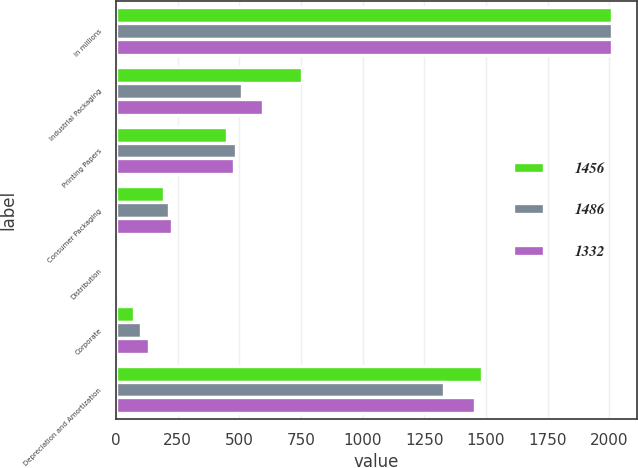Convert chart. <chart><loc_0><loc_0><loc_500><loc_500><stacked_bar_chart><ecel><fcel>In millions<fcel>Industrial Packaging<fcel>Printing Papers<fcel>Consumer Packaging<fcel>Distribution<fcel>Corporate<fcel>Depreciation and Amortization<nl><fcel>1456<fcel>2012<fcel>755<fcel>450<fcel>196<fcel>13<fcel>72<fcel>1486<nl><fcel>1486<fcel>2011<fcel>513<fcel>486<fcel>217<fcel>14<fcel>102<fcel>1332<nl><fcel>1332<fcel>2010<fcel>597<fcel>479<fcel>228<fcel>13<fcel>134<fcel>1456<nl></chart> 